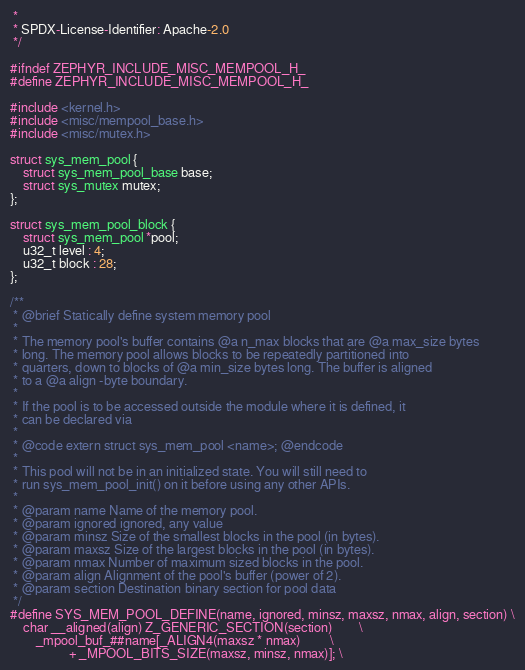Convert code to text. <code><loc_0><loc_0><loc_500><loc_500><_C_> *
 * SPDX-License-Identifier: Apache-2.0
 */

#ifndef ZEPHYR_INCLUDE_MISC_MEMPOOL_H_
#define ZEPHYR_INCLUDE_MISC_MEMPOOL_H_

#include <kernel.h>
#include <misc/mempool_base.h>
#include <misc/mutex.h>

struct sys_mem_pool {
	struct sys_mem_pool_base base;
	struct sys_mutex mutex;
};

struct sys_mem_pool_block {
	struct sys_mem_pool *pool;
	u32_t level : 4;
	u32_t block : 28;
};

/**
 * @brief Statically define system memory pool
 *
 * The memory pool's buffer contains @a n_max blocks that are @a max_size bytes
 * long. The memory pool allows blocks to be repeatedly partitioned into
 * quarters, down to blocks of @a min_size bytes long. The buffer is aligned
 * to a @a align -byte boundary.
 *
 * If the pool is to be accessed outside the module where it is defined, it
 * can be declared via
 *
 * @code extern struct sys_mem_pool <name>; @endcode
 *
 * This pool will not be in an initialized state. You will still need to
 * run sys_mem_pool_init() on it before using any other APIs.
 *
 * @param name Name of the memory pool.
 * @param ignored ignored, any value
 * @param minsz Size of the smallest blocks in the pool (in bytes).
 * @param maxsz Size of the largest blocks in the pool (in bytes).
 * @param nmax Number of maximum sized blocks in the pool.
 * @param align Alignment of the pool's buffer (power of 2).
 * @param section Destination binary section for pool data
 */
#define SYS_MEM_POOL_DEFINE(name, ignored, minsz, maxsz, nmax, align, section) \
	char __aligned(align) Z_GENERIC_SECTION(section)		\
		_mpool_buf_##name[_ALIGN4(maxsz * nmax)			\
				  + _MPOOL_BITS_SIZE(maxsz, minsz, nmax)]; \</code> 